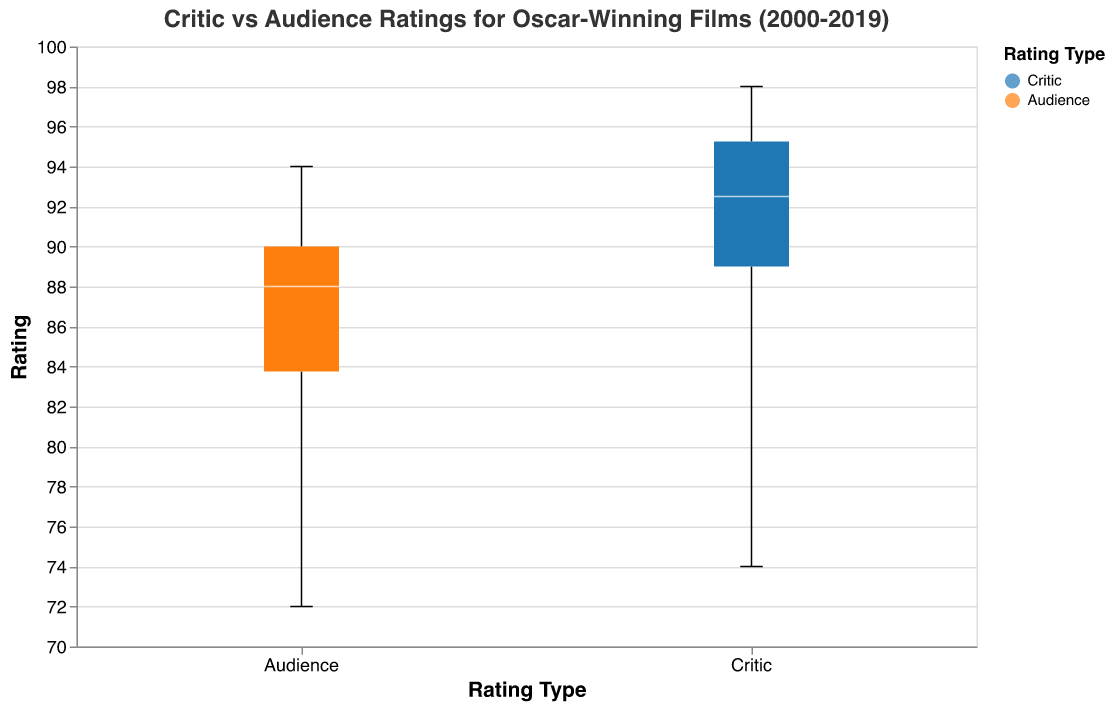What is the title of the plotted figure? The title is displayed at the top of the plot, which is a standard feature for providing context about what the plot represents. The title reads, "Critic vs Audience Ratings for Oscar-Winning Films (2000-2019)."
Answer: Critic vs Audience Ratings for Oscar-Winning Films (2000-2019) What are the two groups compared in the box plots? The x-axis labels the two groups being compared as "Critic" and "Audience," which represent the types of ratings given to the films.
Answer: Critic and Audience What is the range of the audience ratings displayed in the plot? The outliers of the boxplot for audience ratings appear at the extreme ends of the data. The lowest outlier is at approximately 72 and the highest at 94.
Answer: 72 to 94 Which rating type generally has a higher median value? By looking at the median lines in each boxplot, the median for critics is slightly higher compared to the audience.
Answer: Critic Is there more variability in critic ratings or audience ratings? Variability can be assessed by the length of the boxes and the distance between the whiskers in the box plots. The audience ratings show more variability as the box is slightly wider.
Answer: Audience What is the median value of critic ratings? The median is indicated by the line inside the box of the critic ratings box plot, which lies around 94–95.
Answer: 94–95 Which rating type has the highest outlier value above the upper whisker? Checking the ends of the whiskers and the plotted outliers, the highest outlier falls within the critic ratings at approximately 98.
Answer: Critic What is the minimum value of critic ratings within the whiskers? The lower whisker of the critic ratings box plot extends down to approximately 74.
Answer: 74 How do the interquartile ranges (IQR) of critic and audience ratings compare? The IQR is the range between the first and third quartiles. The IQR for critic ratings is smaller than the IQR for audience ratings, indicating that critic ratings are more tightly clustered.
Answer: Critic IQR is smaller What's the relative position of the upper quartile of audience ratings to the median of critic ratings? The upper quartile (top of the box) for audience ratings is below the median line of the critic ratings box plot, indicating lower values in the audience ratings.
Answer: Below 